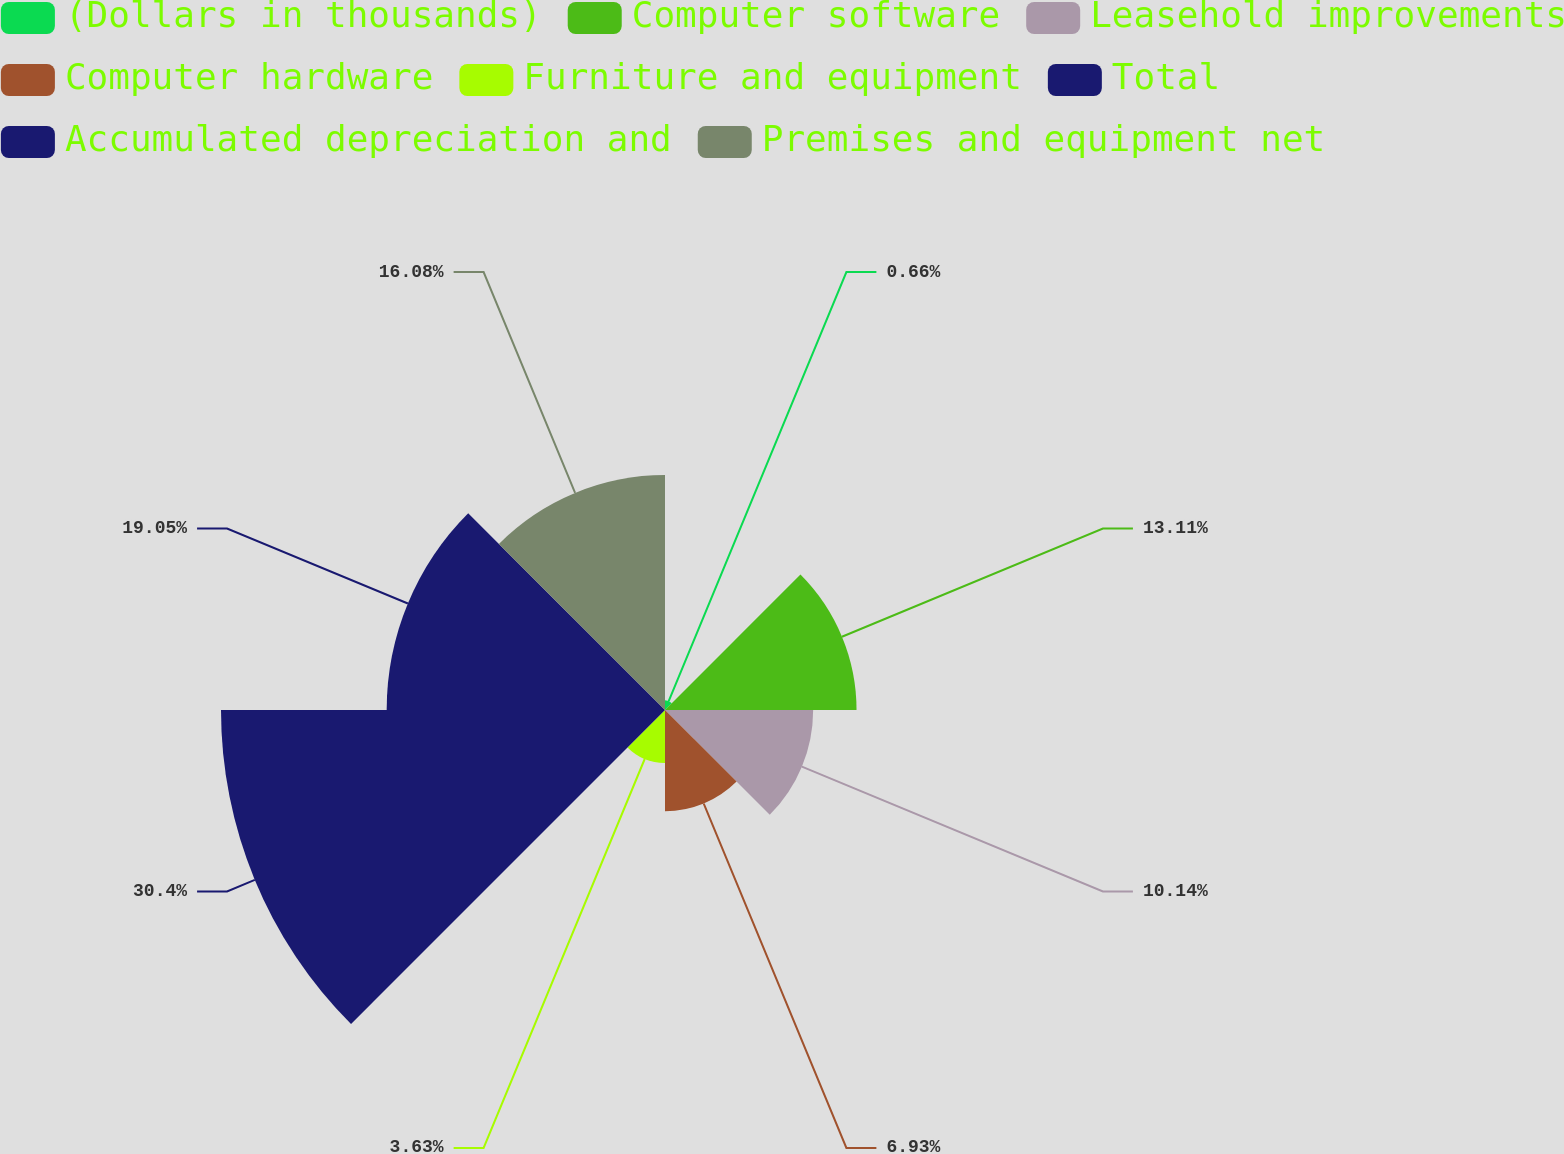<chart> <loc_0><loc_0><loc_500><loc_500><pie_chart><fcel>(Dollars in thousands)<fcel>Computer software<fcel>Leasehold improvements<fcel>Computer hardware<fcel>Furniture and equipment<fcel>Total<fcel>Accumulated depreciation and<fcel>Premises and equipment net<nl><fcel>0.66%<fcel>13.11%<fcel>10.14%<fcel>6.93%<fcel>3.63%<fcel>30.39%<fcel>19.05%<fcel>16.08%<nl></chart> 